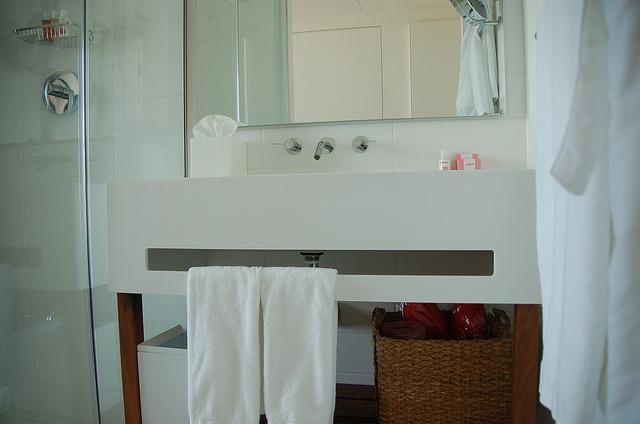How many towels and washcloths can be seen on the shelf?
Give a very brief answer. 2. How many people are wearing blue?
Give a very brief answer. 0. 